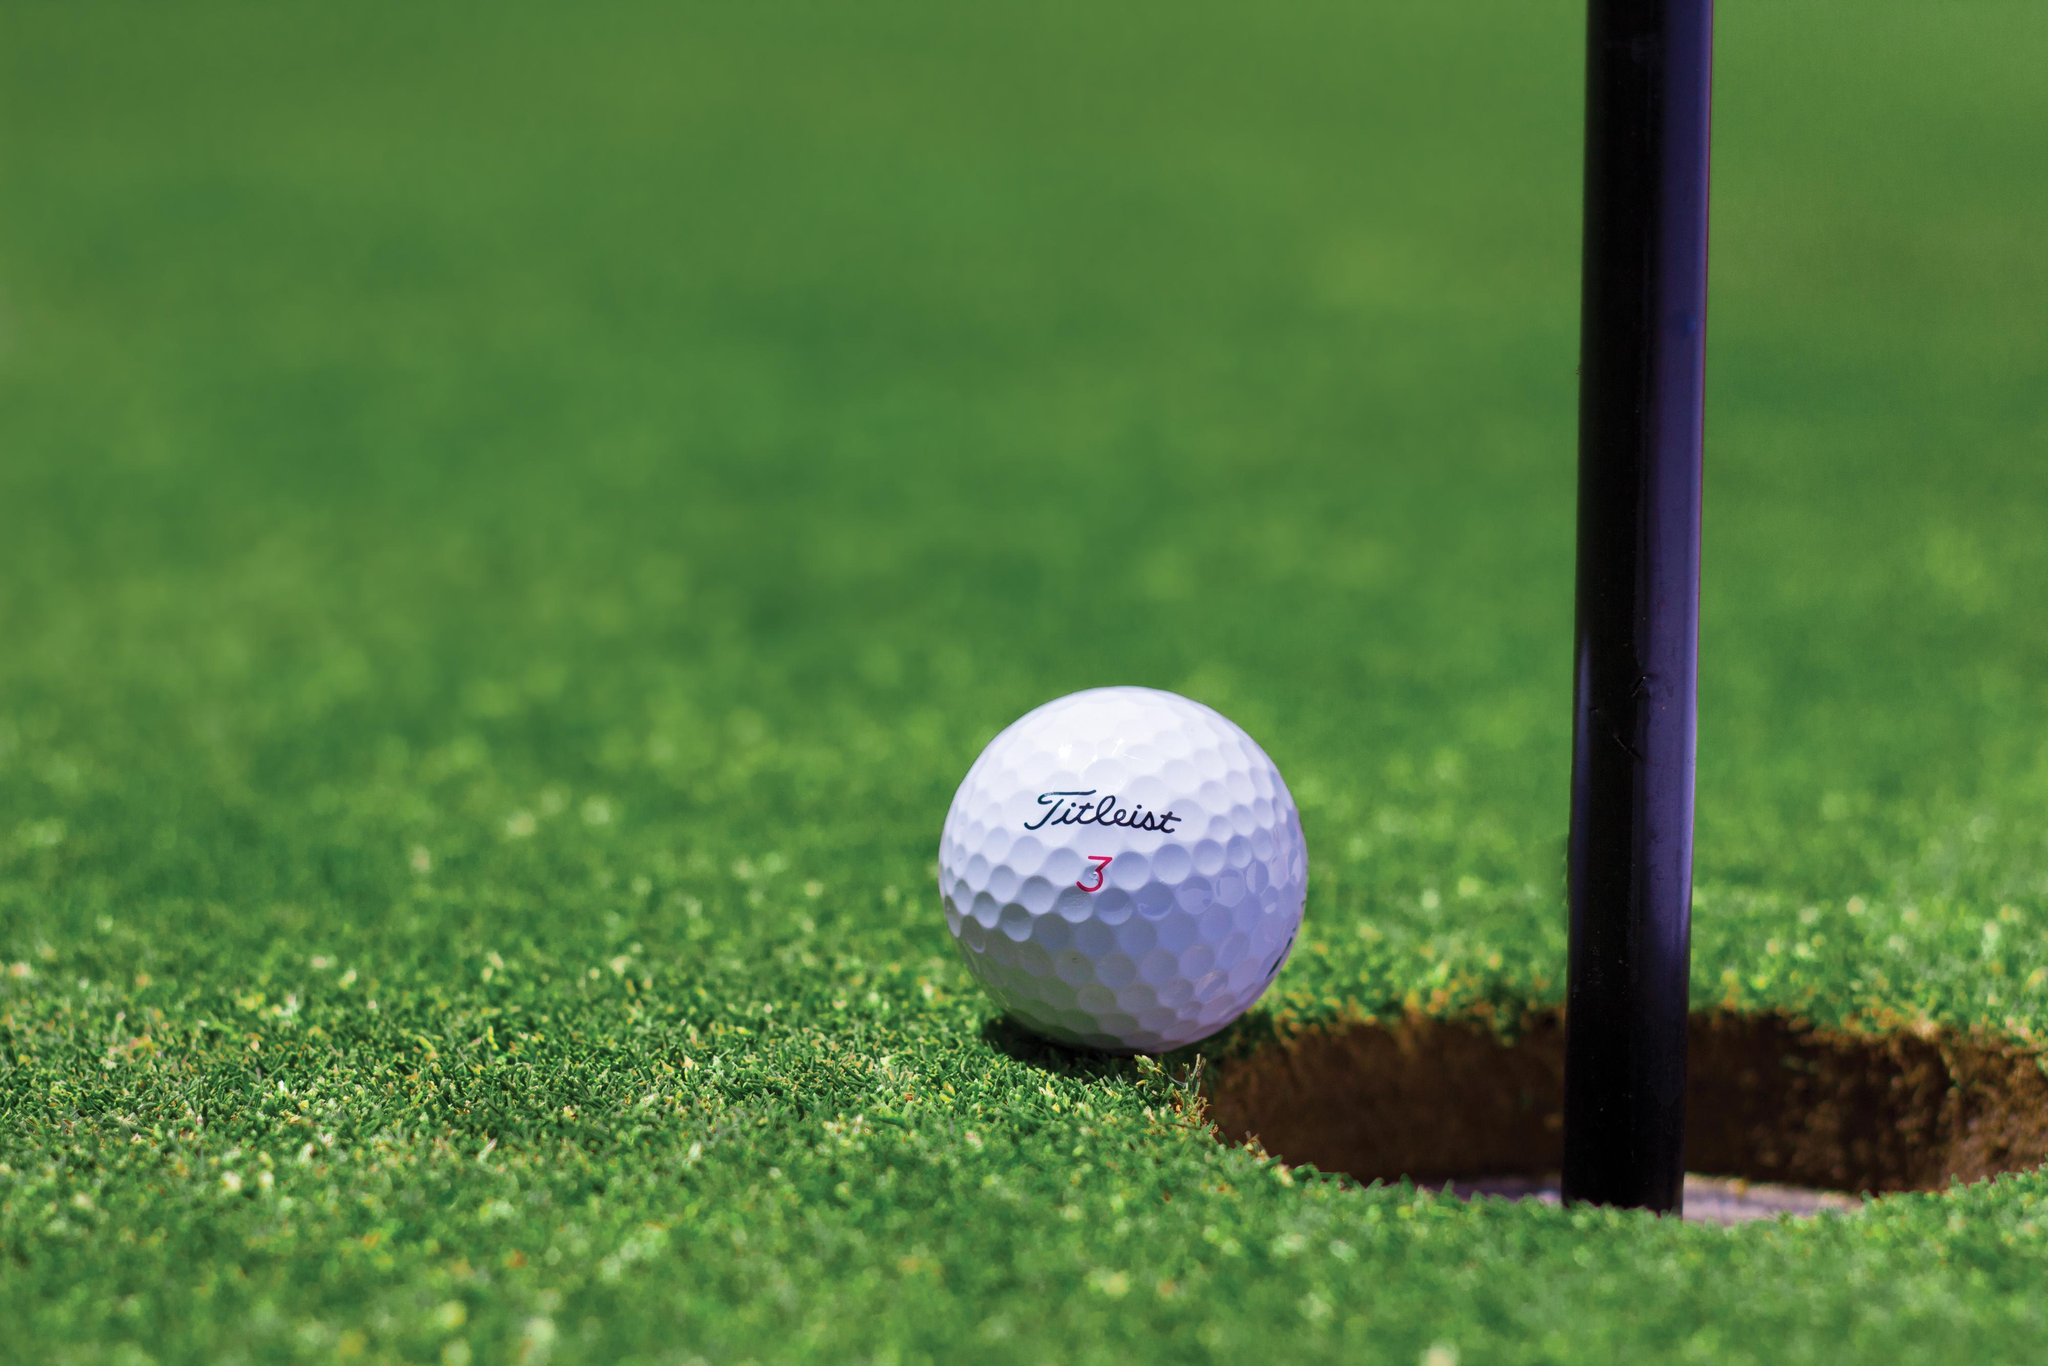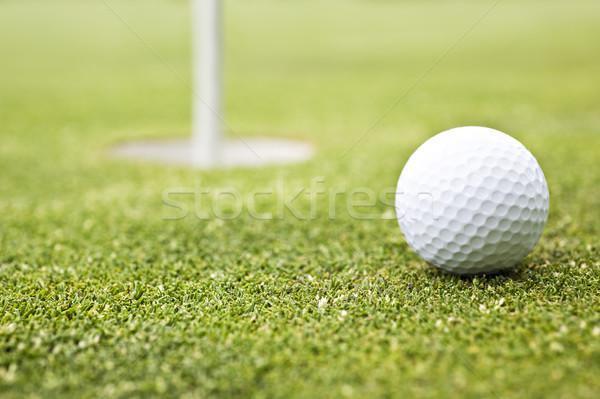The first image is the image on the left, the second image is the image on the right. Evaluate the accuracy of this statement regarding the images: "Left image shows one ball next to a hole on a golf green.". Is it true? Answer yes or no. Yes. 